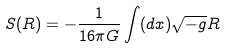<formula> <loc_0><loc_0><loc_500><loc_500>S ( R ) = - \frac { 1 } { 1 6 \pi G } \int ( d x ) \sqrt { - g } R</formula> 